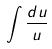<formula> <loc_0><loc_0><loc_500><loc_500>\int \frac { d u } { u }</formula> 